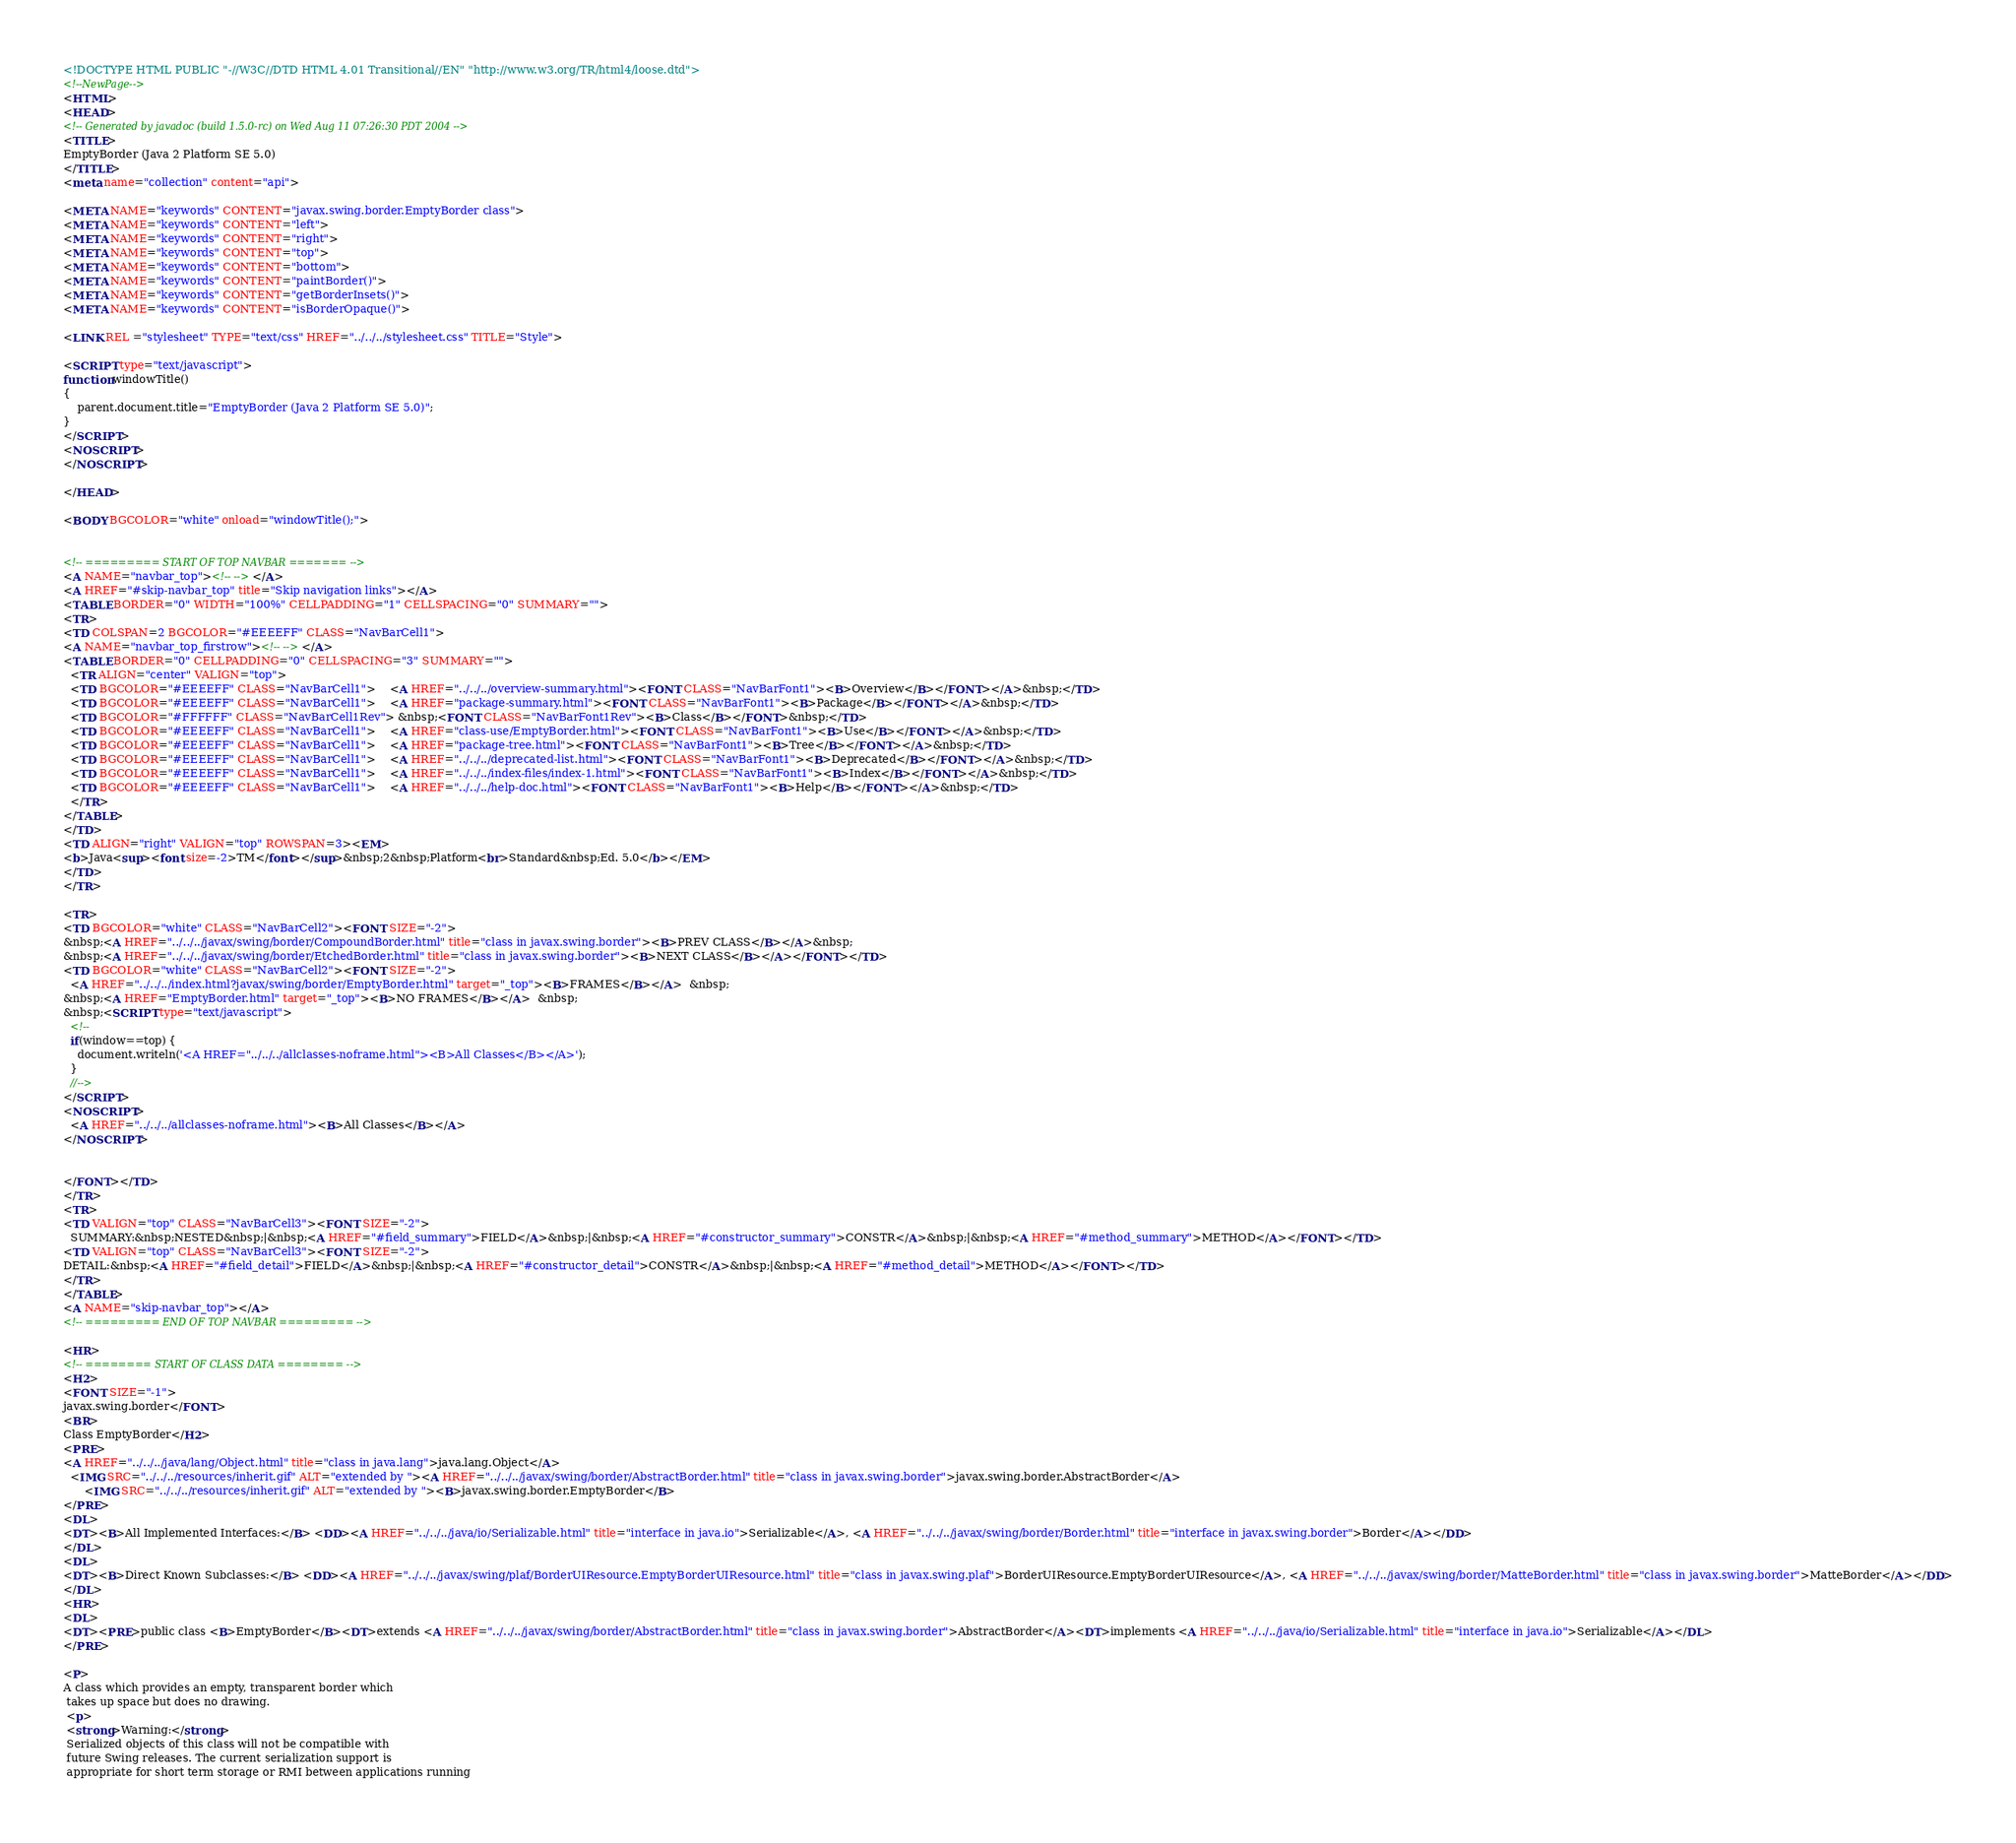<code> <loc_0><loc_0><loc_500><loc_500><_HTML_><!DOCTYPE HTML PUBLIC "-//W3C//DTD HTML 4.01 Transitional//EN" "http://www.w3.org/TR/html4/loose.dtd">
<!--NewPage-->
<HTML>
<HEAD>
<!-- Generated by javadoc (build 1.5.0-rc) on Wed Aug 11 07:26:30 PDT 2004 -->
<TITLE>
EmptyBorder (Java 2 Platform SE 5.0)
</TITLE>
<meta name="collection" content="api">

<META NAME="keywords" CONTENT="javax.swing.border.EmptyBorder class">
<META NAME="keywords" CONTENT="left">
<META NAME="keywords" CONTENT="right">
<META NAME="keywords" CONTENT="top">
<META NAME="keywords" CONTENT="bottom">
<META NAME="keywords" CONTENT="paintBorder()">
<META NAME="keywords" CONTENT="getBorderInsets()">
<META NAME="keywords" CONTENT="isBorderOpaque()">

<LINK REL ="stylesheet" TYPE="text/css" HREF="../../../stylesheet.css" TITLE="Style">

<SCRIPT type="text/javascript">
function windowTitle()
{
    parent.document.title="EmptyBorder (Java 2 Platform SE 5.0)";
}
</SCRIPT>
<NOSCRIPT>
</NOSCRIPT>

</HEAD>

<BODY BGCOLOR="white" onload="windowTitle();">


<!-- ========= START OF TOP NAVBAR ======= -->
<A NAME="navbar_top"><!-- --></A>
<A HREF="#skip-navbar_top" title="Skip navigation links"></A>
<TABLE BORDER="0" WIDTH="100%" CELLPADDING="1" CELLSPACING="0" SUMMARY="">
<TR>
<TD COLSPAN=2 BGCOLOR="#EEEEFF" CLASS="NavBarCell1">
<A NAME="navbar_top_firstrow"><!-- --></A>
<TABLE BORDER="0" CELLPADDING="0" CELLSPACING="3" SUMMARY="">
  <TR ALIGN="center" VALIGN="top">
  <TD BGCOLOR="#EEEEFF" CLASS="NavBarCell1">    <A HREF="../../../overview-summary.html"><FONT CLASS="NavBarFont1"><B>Overview</B></FONT></A>&nbsp;</TD>
  <TD BGCOLOR="#EEEEFF" CLASS="NavBarCell1">    <A HREF="package-summary.html"><FONT CLASS="NavBarFont1"><B>Package</B></FONT></A>&nbsp;</TD>
  <TD BGCOLOR="#FFFFFF" CLASS="NavBarCell1Rev"> &nbsp;<FONT CLASS="NavBarFont1Rev"><B>Class</B></FONT>&nbsp;</TD>
  <TD BGCOLOR="#EEEEFF" CLASS="NavBarCell1">    <A HREF="class-use/EmptyBorder.html"><FONT CLASS="NavBarFont1"><B>Use</B></FONT></A>&nbsp;</TD>
  <TD BGCOLOR="#EEEEFF" CLASS="NavBarCell1">    <A HREF="package-tree.html"><FONT CLASS="NavBarFont1"><B>Tree</B></FONT></A>&nbsp;</TD>
  <TD BGCOLOR="#EEEEFF" CLASS="NavBarCell1">    <A HREF="../../../deprecated-list.html"><FONT CLASS="NavBarFont1"><B>Deprecated</B></FONT></A>&nbsp;</TD>
  <TD BGCOLOR="#EEEEFF" CLASS="NavBarCell1">    <A HREF="../../../index-files/index-1.html"><FONT CLASS="NavBarFont1"><B>Index</B></FONT></A>&nbsp;</TD>
  <TD BGCOLOR="#EEEEFF" CLASS="NavBarCell1">    <A HREF="../../../help-doc.html"><FONT CLASS="NavBarFont1"><B>Help</B></FONT></A>&nbsp;</TD>
  </TR>
</TABLE>
</TD>
<TD ALIGN="right" VALIGN="top" ROWSPAN=3><EM>
<b>Java<sup><font size=-2>TM</font></sup>&nbsp;2&nbsp;Platform<br>Standard&nbsp;Ed. 5.0</b></EM>
</TD>
</TR>

<TR>
<TD BGCOLOR="white" CLASS="NavBarCell2"><FONT SIZE="-2">
&nbsp;<A HREF="../../../javax/swing/border/CompoundBorder.html" title="class in javax.swing.border"><B>PREV CLASS</B></A>&nbsp;
&nbsp;<A HREF="../../../javax/swing/border/EtchedBorder.html" title="class in javax.swing.border"><B>NEXT CLASS</B></A></FONT></TD>
<TD BGCOLOR="white" CLASS="NavBarCell2"><FONT SIZE="-2">
  <A HREF="../../../index.html?javax/swing/border/EmptyBorder.html" target="_top"><B>FRAMES</B></A>  &nbsp;
&nbsp;<A HREF="EmptyBorder.html" target="_top"><B>NO FRAMES</B></A>  &nbsp;
&nbsp;<SCRIPT type="text/javascript">
  <!--
  if(window==top) {
    document.writeln('<A HREF="../../../allclasses-noframe.html"><B>All Classes</B></A>');
  }
  //-->
</SCRIPT>
<NOSCRIPT>
  <A HREF="../../../allclasses-noframe.html"><B>All Classes</B></A>
</NOSCRIPT>


</FONT></TD>
</TR>
<TR>
<TD VALIGN="top" CLASS="NavBarCell3"><FONT SIZE="-2">
  SUMMARY:&nbsp;NESTED&nbsp;|&nbsp;<A HREF="#field_summary">FIELD</A>&nbsp;|&nbsp;<A HREF="#constructor_summary">CONSTR</A>&nbsp;|&nbsp;<A HREF="#method_summary">METHOD</A></FONT></TD>
<TD VALIGN="top" CLASS="NavBarCell3"><FONT SIZE="-2">
DETAIL:&nbsp;<A HREF="#field_detail">FIELD</A>&nbsp;|&nbsp;<A HREF="#constructor_detail">CONSTR</A>&nbsp;|&nbsp;<A HREF="#method_detail">METHOD</A></FONT></TD>
</TR>
</TABLE>
<A NAME="skip-navbar_top"></A>
<!-- ========= END OF TOP NAVBAR ========= -->

<HR>
<!-- ======== START OF CLASS DATA ======== -->
<H2>
<FONT SIZE="-1">
javax.swing.border</FONT>
<BR>
Class EmptyBorder</H2>
<PRE>
<A HREF="../../../java/lang/Object.html" title="class in java.lang">java.lang.Object</A>
  <IMG SRC="../../../resources/inherit.gif" ALT="extended by "><A HREF="../../../javax/swing/border/AbstractBorder.html" title="class in javax.swing.border">javax.swing.border.AbstractBorder</A>
      <IMG SRC="../../../resources/inherit.gif" ALT="extended by "><B>javax.swing.border.EmptyBorder</B>
</PRE>
<DL>
<DT><B>All Implemented Interfaces:</B> <DD><A HREF="../../../java/io/Serializable.html" title="interface in java.io">Serializable</A>, <A HREF="../../../javax/swing/border/Border.html" title="interface in javax.swing.border">Border</A></DD>
</DL>
<DL>
<DT><B>Direct Known Subclasses:</B> <DD><A HREF="../../../javax/swing/plaf/BorderUIResource.EmptyBorderUIResource.html" title="class in javax.swing.plaf">BorderUIResource.EmptyBorderUIResource</A>, <A HREF="../../../javax/swing/border/MatteBorder.html" title="class in javax.swing.border">MatteBorder</A></DD>
</DL>
<HR>
<DL>
<DT><PRE>public class <B>EmptyBorder</B><DT>extends <A HREF="../../../javax/swing/border/AbstractBorder.html" title="class in javax.swing.border">AbstractBorder</A><DT>implements <A HREF="../../../java/io/Serializable.html" title="interface in java.io">Serializable</A></DL>
</PRE>

<P>
A class which provides an empty, transparent border which
 takes up space but does no drawing.
 <p>
 <strong>Warning:</strong>
 Serialized objects of this class will not be compatible with
 future Swing releases. The current serialization support is
 appropriate for short term storage or RMI between applications running</code> 